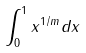<formula> <loc_0><loc_0><loc_500><loc_500>\int _ { 0 } ^ { 1 } x ^ { 1 / m } d x</formula> 